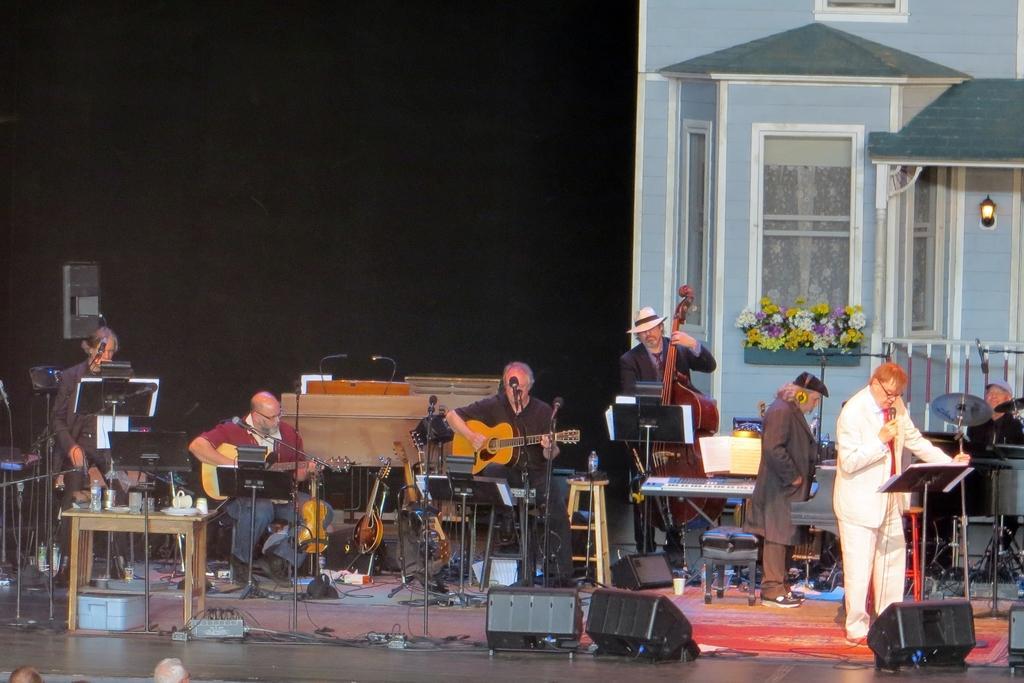Can you describe this image briefly? There are group of people playing musical instruments and two among them is singing in front of a mic. 